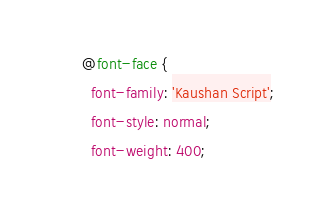Convert code to text. <code><loc_0><loc_0><loc_500><loc_500><_CSS_>@font-face {
  font-family: 'Kaushan Script';
  font-style: normal;
  font-weight: 400;</code> 